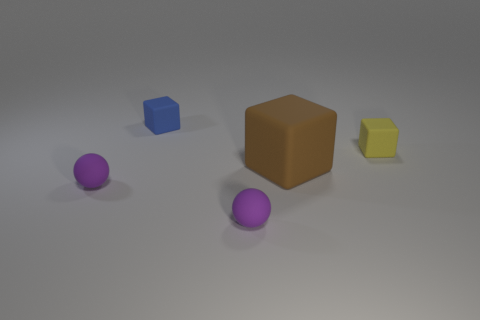How many brown matte objects have the same size as the blue rubber block?
Keep it short and to the point. 0. There is a large thing that is the same material as the blue block; what shape is it?
Offer a very short reply. Cube. What material is the yellow block?
Your answer should be compact. Rubber. How many objects are blue rubber things or brown rubber cubes?
Keep it short and to the point. 2. There is a block that is behind the yellow block; what size is it?
Make the answer very short. Small. How many other objects are there of the same material as the brown cube?
Give a very brief answer. 4. There is a small thing that is right of the large cube; are there any small things that are to the left of it?
Provide a succinct answer. Yes. The large object that is the same shape as the tiny yellow thing is what color?
Provide a succinct answer. Brown. The brown rubber cube has what size?
Your answer should be compact. Large. Are there fewer tiny blue blocks on the left side of the blue object than tiny matte spheres?
Keep it short and to the point. Yes. 